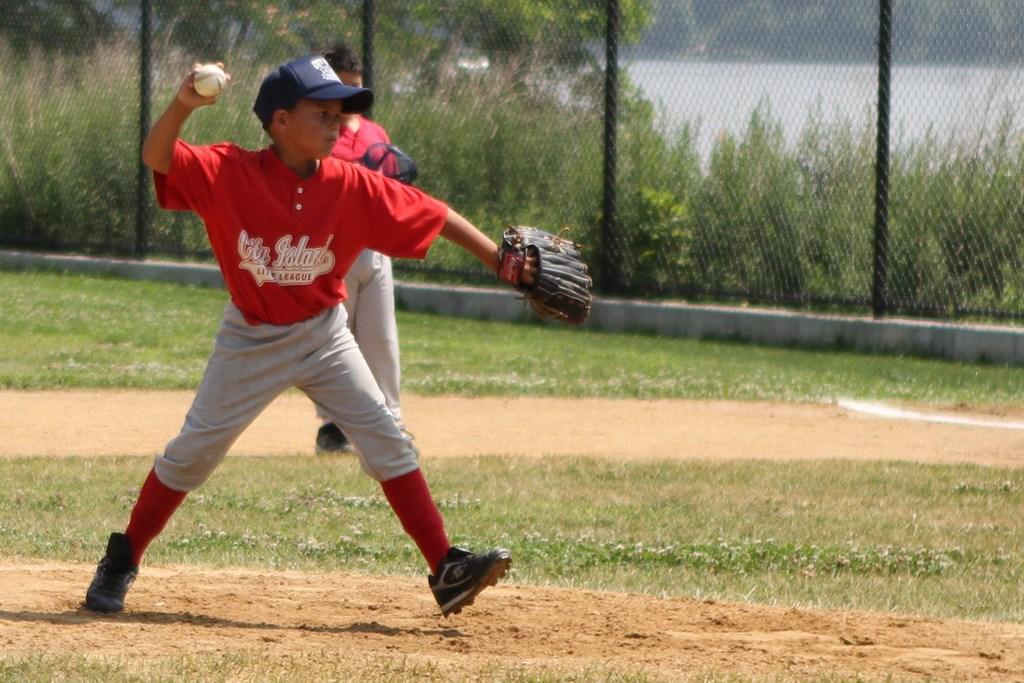What team does the boy play for?
Keep it short and to the point. City island. What is written on the front of the boy's red shirt?
Your answer should be compact. City island. 